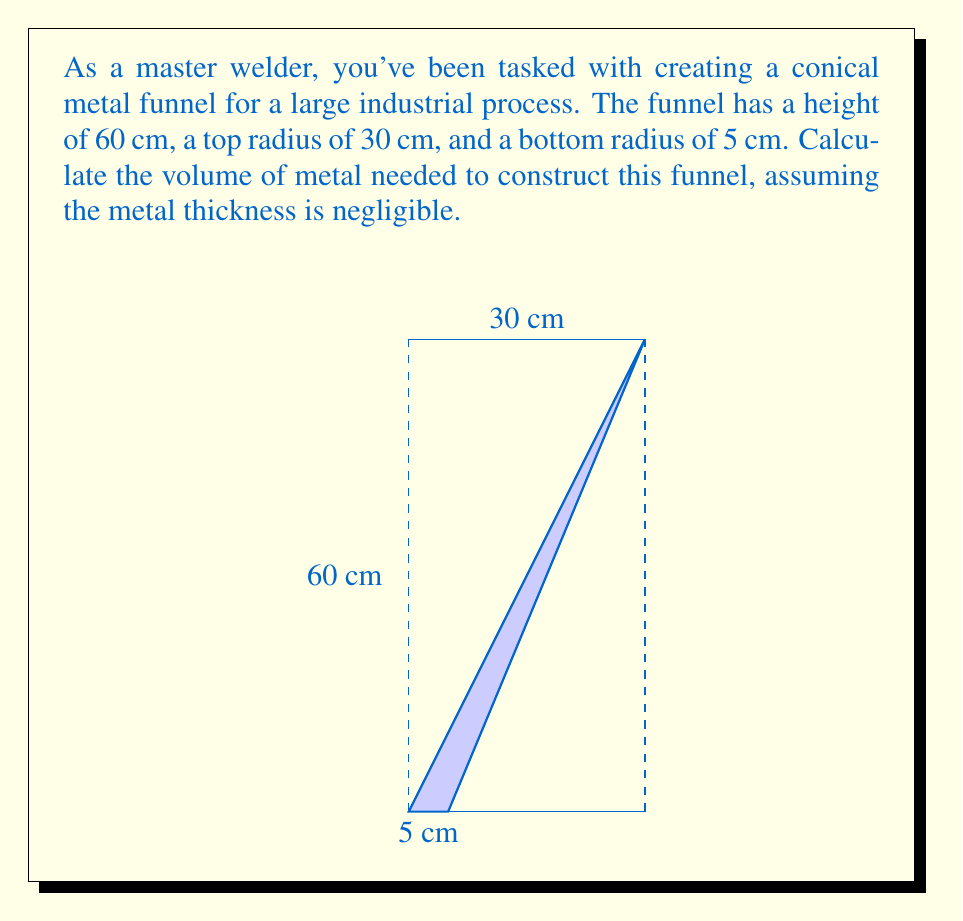Could you help me with this problem? To find the volume of the conical funnel, we need to use the method of integration. Here's how we can approach this problem:

1) First, let's set up our coordinate system. We'll place the origin at the bottom of the funnel and let the z-axis run along the height of the funnel.

2) The radius of any cross-section of the funnel at height z can be described by the equation:

   $$r(z) = r_2 + \frac{r_1 - r_2}{h}z$$

   where $r_1$ is the top radius, $r_2$ is the bottom radius, and $h$ is the height.

3) The volume of a solid of revolution can be calculated using the formula:

   $$V = \pi \int_0^h [r(z)]^2 dz$$

4) Substituting our radius function:

   $$V = \pi \int_0^h \left(r_2 + \frac{r_1 - r_2}{h}z\right)^2 dz$$

5) Let's substitute the given values: $r_1 = 30$ cm, $r_2 = 5$ cm, $h = 60$ cm

   $$V = \pi \int_0^{60} \left(5 + \frac{25}{60}z\right)^2 dz$$

6) Expand the integrand:

   $$V = \pi \int_0^{60} \left(25 + \frac{250}{60}z + \frac{625}{3600}z^2\right) dz$$

7) Integrate:

   $$V = \pi \left[25z + \frac{125}{60}z^2 + \frac{625}{10800}z^3\right]_0^{60}$$

8) Evaluate the integral:

   $$V = \pi \left[(1500 + 7500 + 12500) - 0\right]$$
   $$V = 21500\pi \text{ cm}^3$$

Therefore, the volume of the metal funnel is $21500\pi$ cubic centimeters.
Answer: $21500\pi \text{ cm}^3$ or approximately $67541.57 \text{ cm}^3$ 